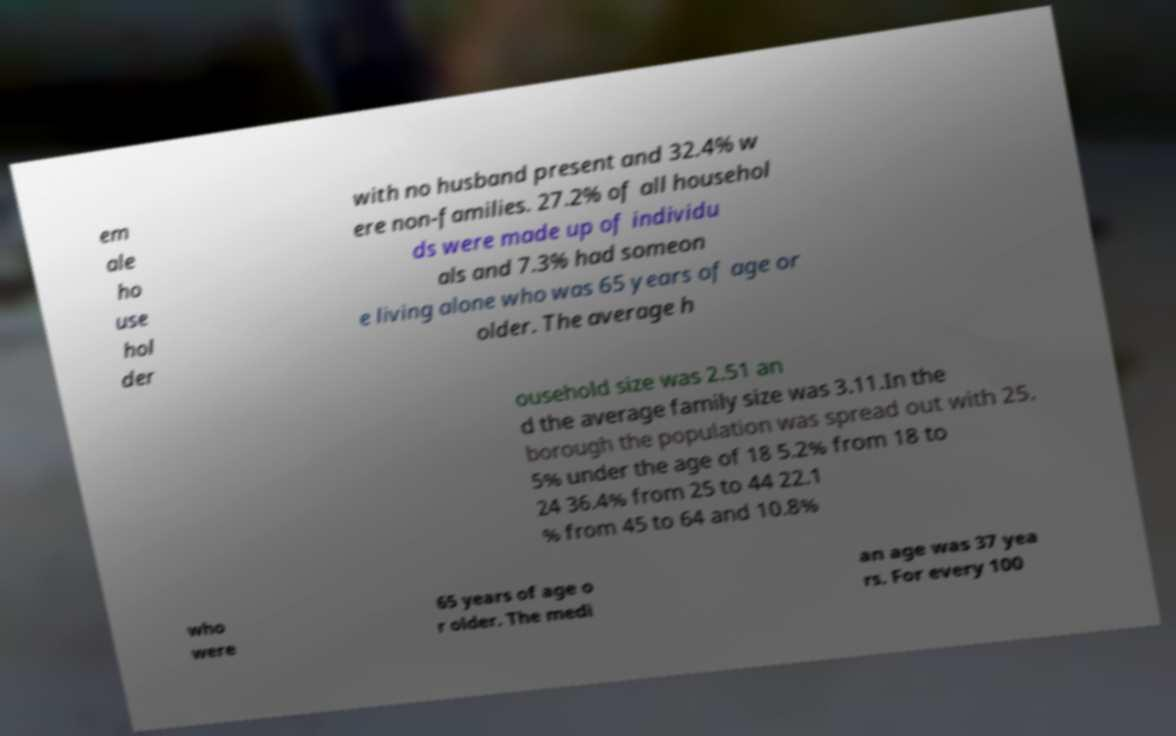I need the written content from this picture converted into text. Can you do that? em ale ho use hol der with no husband present and 32.4% w ere non-families. 27.2% of all househol ds were made up of individu als and 7.3% had someon e living alone who was 65 years of age or older. The average h ousehold size was 2.51 an d the average family size was 3.11.In the borough the population was spread out with 25. 5% under the age of 18 5.2% from 18 to 24 36.4% from 25 to 44 22.1 % from 45 to 64 and 10.8% who were 65 years of age o r older. The medi an age was 37 yea rs. For every 100 